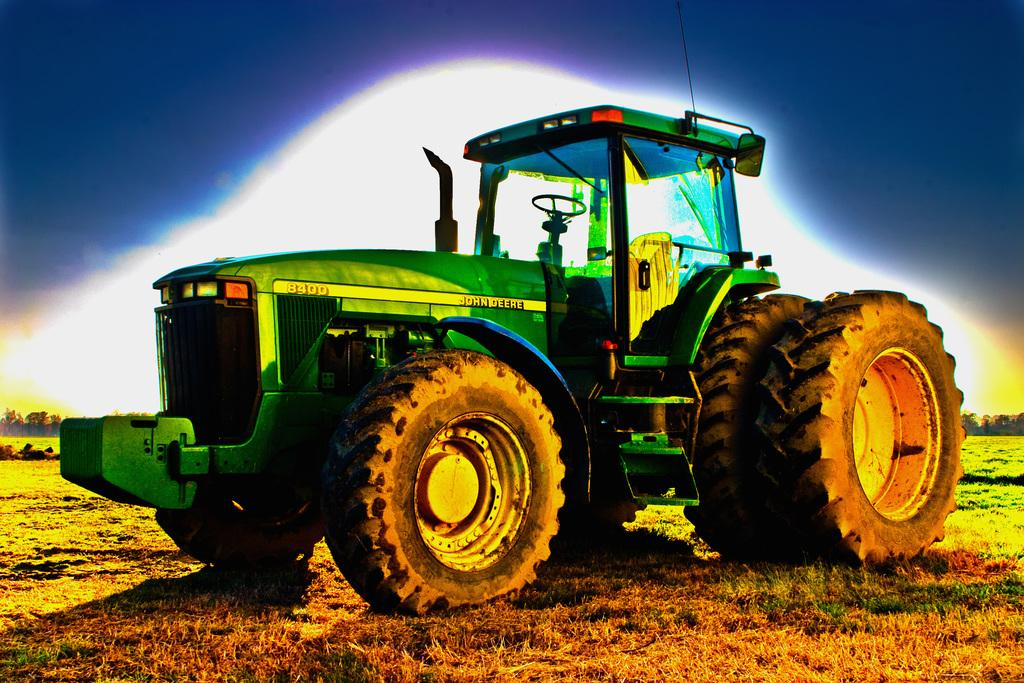What color is the vehicle in the image? The vehicle in the image is green-colored. Where is the vehicle located in the image? The vehicle is in the center of the image. What type of terrain is visible in the image? There is an open grass ground visible in the image. What is the degree of the argument between the vehicle and the grass in the image? There is no argument between the vehicle and the grass in the image, as they are inanimate objects and cannot engage in arguments. 